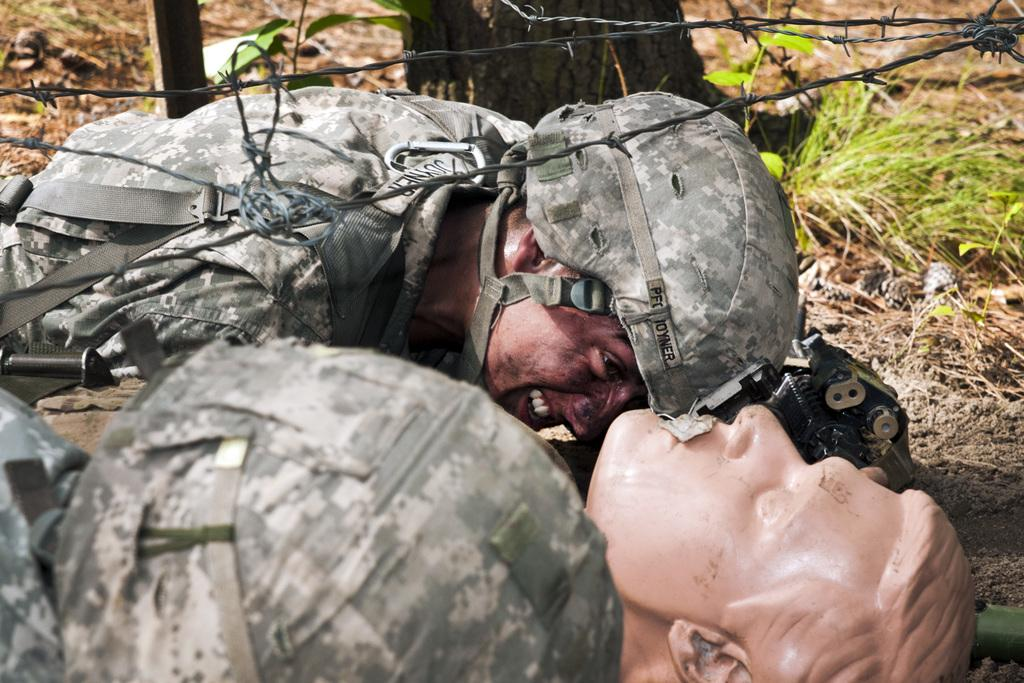What is the main subject of the image? There is a statue of a person in the image. What else can be seen in the image? There is a man on the ground in the image. What type of natural environment is visible in the background? There is grass visible in the background of the image. What else can be seen in the background of the image? There are objects present in the background of the image. How many mice are hiding under the statue in the image? There are no mice present in the image. What type of bed is the man lying on in the image? There is no bed present in the image; the man is lying on the ground. 